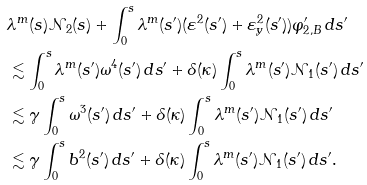<formula> <loc_0><loc_0><loc_500><loc_500>& \lambda ^ { m } ( s ) \mathcal { N } _ { 2 } ( s ) + \int _ { 0 } ^ { s } \lambda ^ { m } ( s ^ { \prime } ) ( \varepsilon ^ { 2 } ( s ^ { \prime } ) + \varepsilon _ { y } ^ { 2 } ( s ^ { \prime } ) ) \varphi _ { 2 , B } ^ { \prime } \, d s ^ { \prime } \\ & \lesssim \int _ { 0 } ^ { s } \lambda ^ { m } ( s ^ { \prime } ) \omega ^ { 4 } ( s ^ { \prime } ) \, d s ^ { \prime } + \delta ( \kappa ) \int _ { 0 } ^ { s } \lambda ^ { m } ( s ^ { \prime } ) \mathcal { N } _ { 1 } ( s ^ { \prime } ) \, d s ^ { \prime } \\ & \lesssim \gamma \int _ { 0 } ^ { s } \omega ^ { 3 } ( s ^ { \prime } ) \, d s ^ { \prime } + \delta ( \kappa ) \int _ { 0 } ^ { s } \lambda ^ { m } ( s ^ { \prime } ) \mathcal { N } _ { 1 } ( s ^ { \prime } ) \, d s ^ { \prime } \\ & \lesssim \gamma \int _ { 0 } ^ { s } b ^ { 2 } ( s ^ { \prime } ) \, d s ^ { \prime } + \delta ( \kappa ) \int _ { 0 } ^ { s } \lambda ^ { m } ( s ^ { \prime } ) \mathcal { N } _ { 1 } ( s ^ { \prime } ) \, d s ^ { \prime } .</formula> 